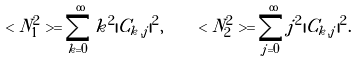<formula> <loc_0><loc_0><loc_500><loc_500>< N ^ { 2 } _ { 1 } > = \sum ^ { \infty } _ { k = 0 } k ^ { 2 } | C _ { k , j } | ^ { 2 } , \quad < N ^ { 2 } _ { 2 } > = \sum ^ { \infty } _ { j = 0 } j ^ { 2 } | C _ { k , j } | ^ { 2 } .</formula> 